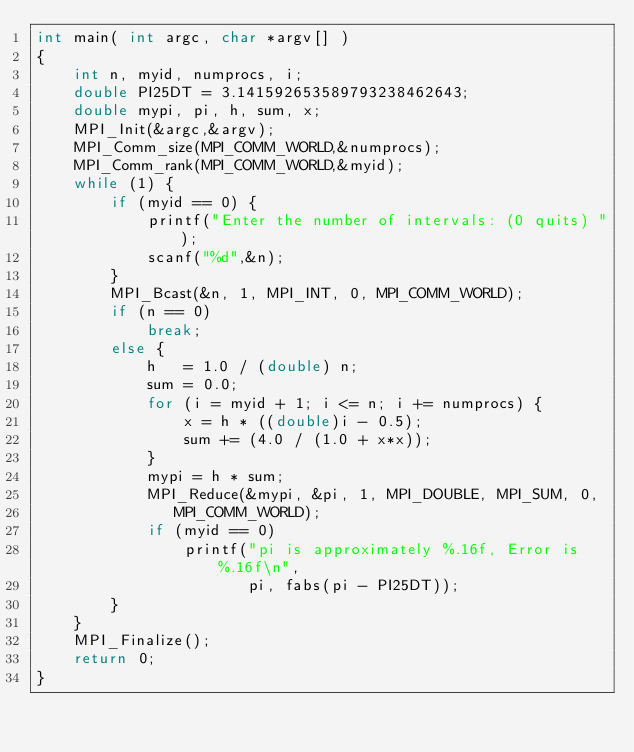Convert code to text. <code><loc_0><loc_0><loc_500><loc_500><_C_>int main( int argc, char *argv[] ) 
{ 
    int n, myid, numprocs, i; 
    double PI25DT = 3.141592653589793238462643; 
    double mypi, pi, h, sum, x; 
    MPI_Init(&argc,&argv); 
    MPI_Comm_size(MPI_COMM_WORLD,&numprocs); 
    MPI_Comm_rank(MPI_COMM_WORLD,&myid); 
    while (1) { 
        if (myid == 0) { 
            printf("Enter the number of intervals: (0 quits) "); 
            scanf("%d",&n); 
        } 
        MPI_Bcast(&n, 1, MPI_INT, 0, MPI_COMM_WORLD); 
        if (n == 0) 
            break; 
        else { 
            h   = 1.0 / (double) n; 
            sum = 0.0; 
            for (i = myid + 1; i <= n; i += numprocs) { 
                x = h * ((double)i - 0.5); 
                sum += (4.0 / (1.0 + x*x)); 
            } 
            mypi = h * sum; 
            MPI_Reduce(&mypi, &pi, 1, MPI_DOUBLE, MPI_SUM, 0, 
		       MPI_COMM_WORLD); 
            if (myid == 0)  
                printf("pi is approximately %.16f, Error is %.16f\n", 
                       pi, fabs(pi - PI25DT)); 
        } 
    } 
    MPI_Finalize(); 
    return 0; 
} 
</code> 